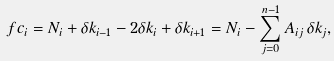<formula> <loc_0><loc_0><loc_500><loc_500>\ f c _ { i } = N _ { i } + \delta k _ { i - 1 } - 2 \delta k _ { i } + \delta k _ { i + 1 } = N _ { i } - \sum _ { j = 0 } ^ { n - 1 } A _ { i j } \, \delta k _ { j } ,</formula> 